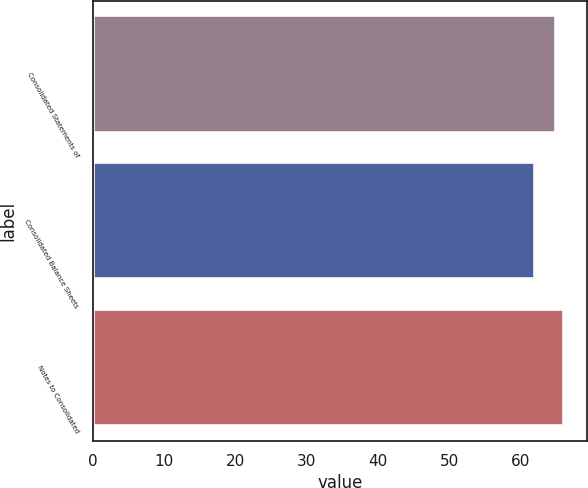Convert chart to OTSL. <chart><loc_0><loc_0><loc_500><loc_500><bar_chart><fcel>Consolidated Statements of<fcel>Consolidated Balance Sheets<fcel>Notes to Consolidated<nl><fcel>65<fcel>62<fcel>66<nl></chart> 